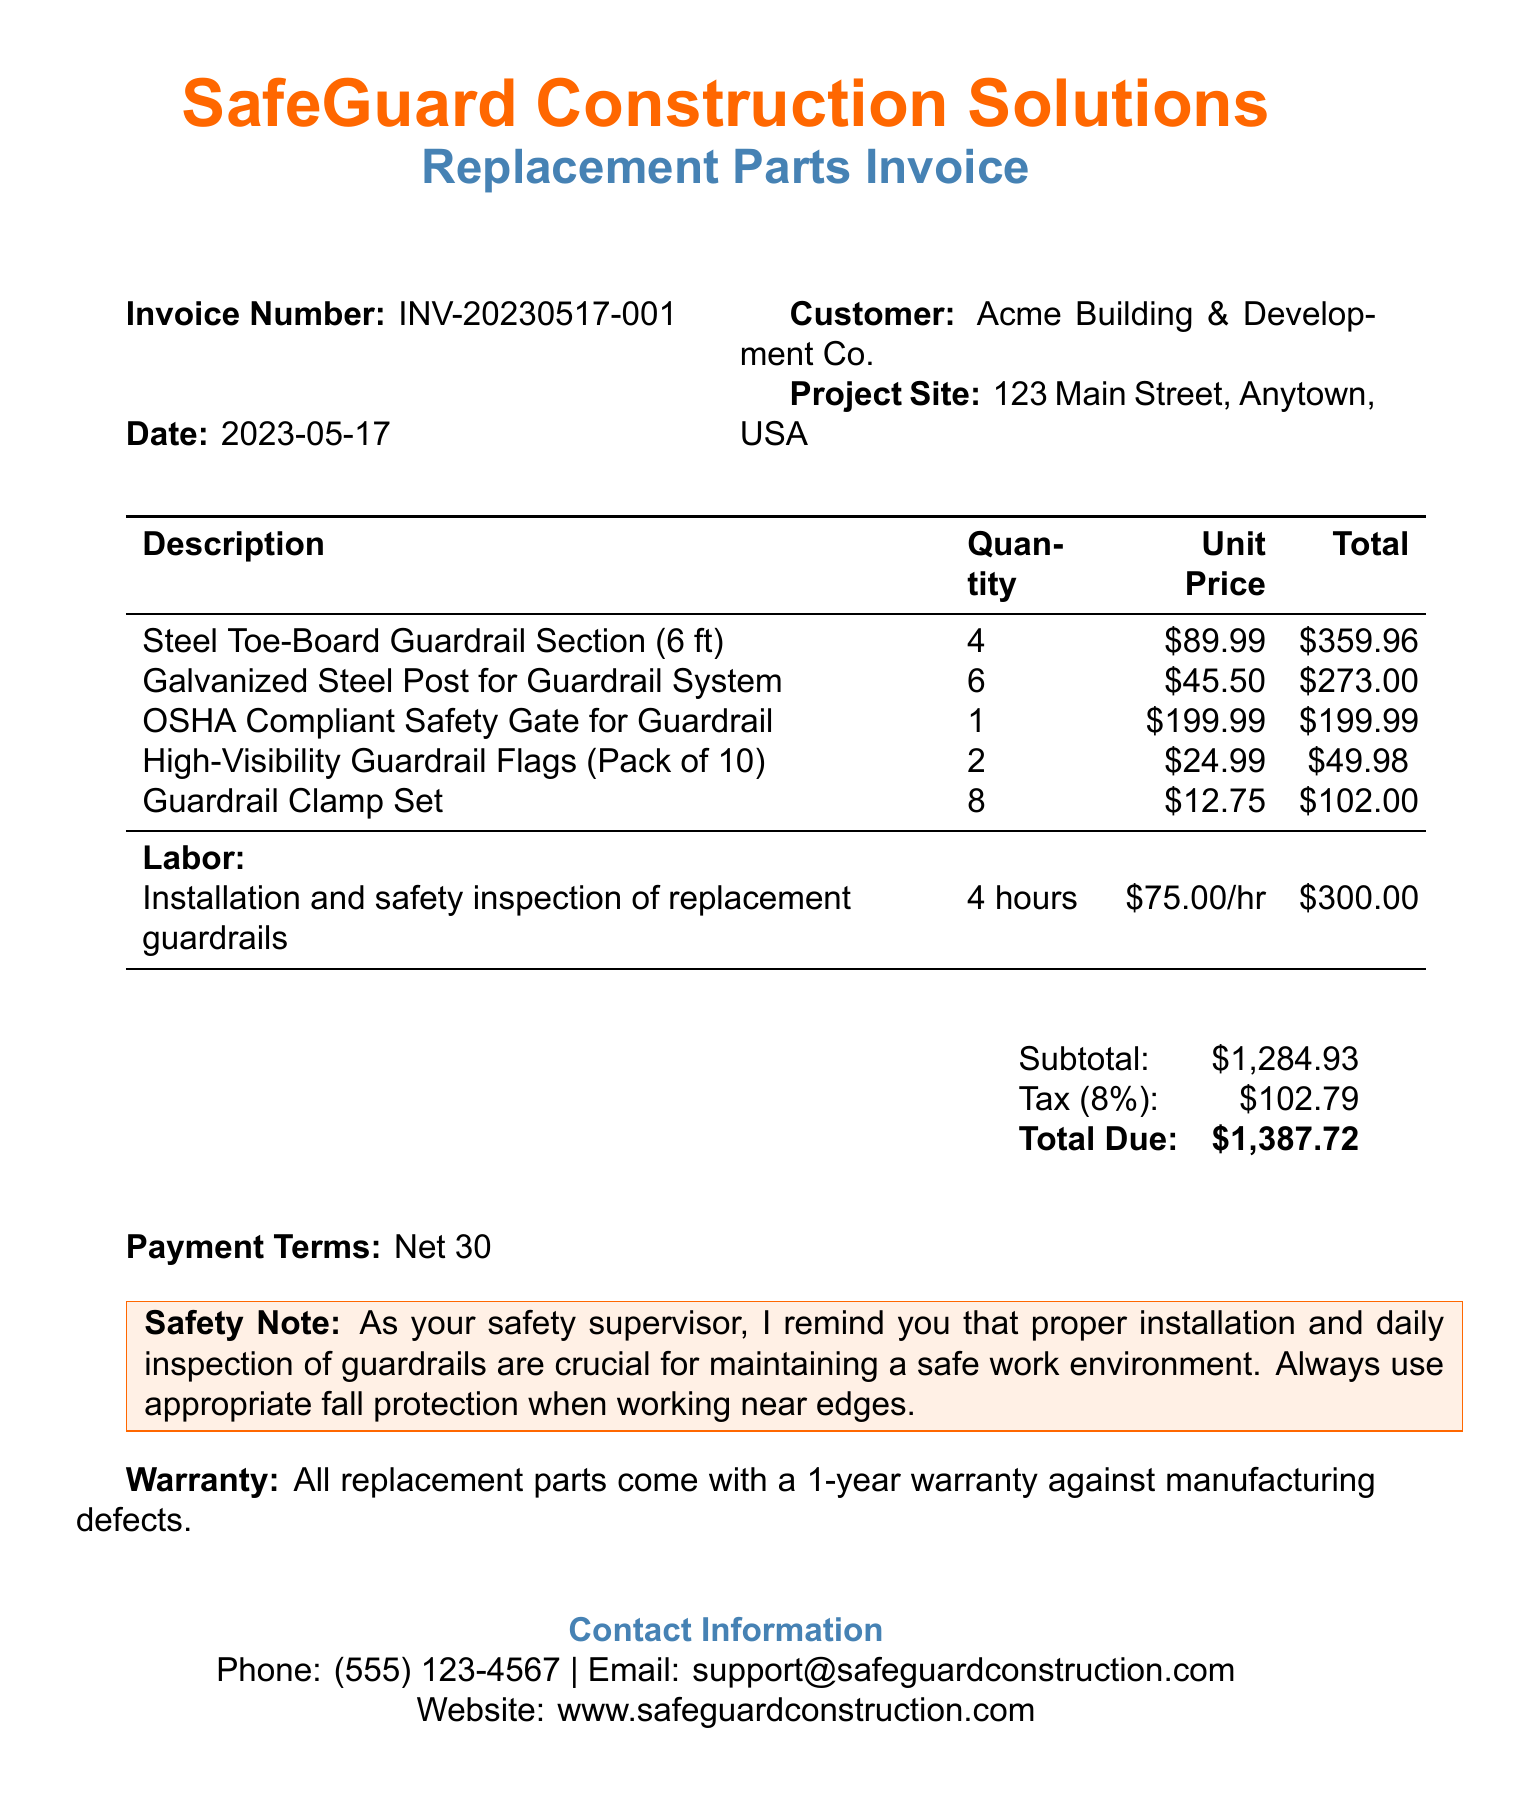What is the invoice number? The invoice number is specified as a unique identifier for the document, which helps in tracking and reference.
Answer: INV-20230517-001 What date was the invoice issued? The date indicates when the invoice was generated and provides a timeline for payment terms.
Answer: 2023-05-17 How many Steel Toe-Board Guardrail Sections were ordered? The quantity provides specific information about how many units of a particular item were purchased.
Answer: 4 What is the total amount due for the invoice? The total due is the final amount calculated after adding subtotal and tax, and represents what the customer needs to pay.
Answer: $1,387.72 What is the tax rate applied to the invoice? The tax rate is important for calculating the additional charges based on the subtotal of the items.
Answer: 8% How many hours were billed for labor? The hours billed indicates the time accounted for labor services performed related to the items in the invoice.
Answer: 4 What warranty is provided for the replacement parts? The warranty outlines the conditions under which the replacement parts can be returned or exchanged if defects are found.
Answer: 1-year warranty against manufacturing defects What is included in the safety note? The safety note provides crucial guidelines for ensuring safety during installation and use of guardrails, highlighting responsibilities.
Answer: Proper installation and daily inspection of guardrails are crucial for maintaining a safe work environment Which company provided the invoice? The company name indicates the business responsible for the products and services being billed in the invoice.
Answer: SafeGuard Construction Solutions 